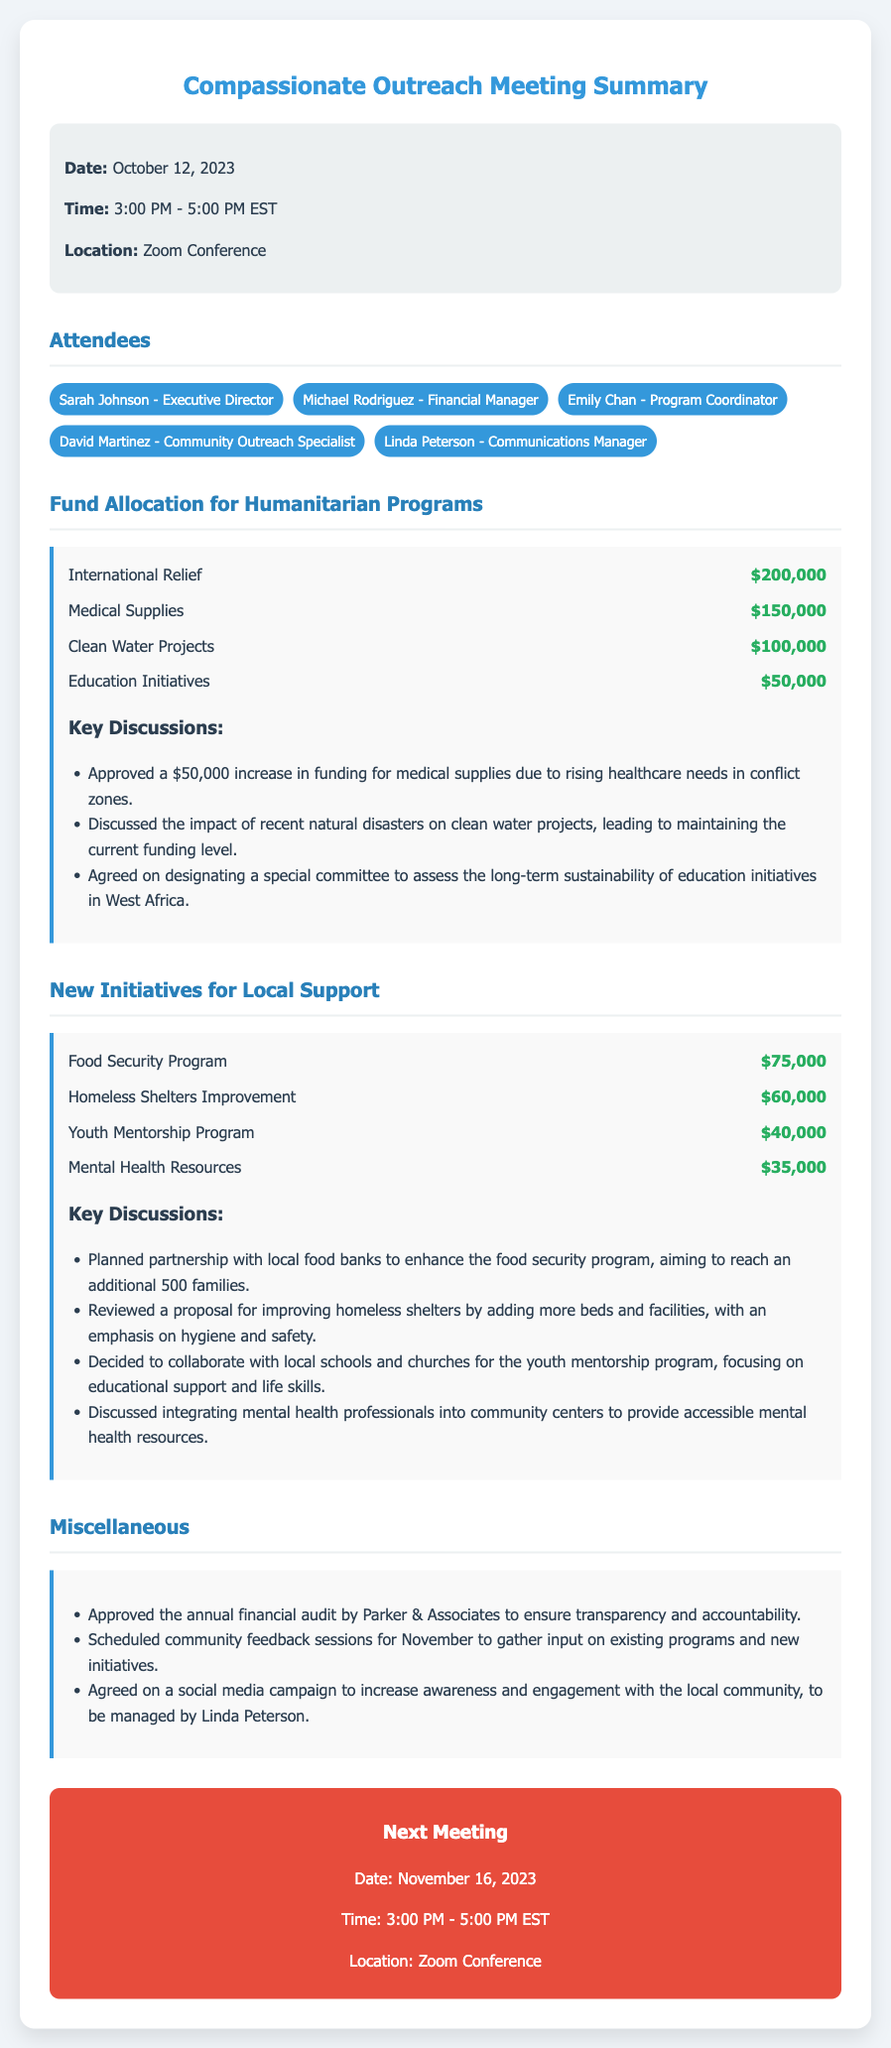What is the date of the meeting? The date of the meeting is specifically stated in the document as October 12, 2023.
Answer: October 12, 2023 Who is the Executive Director? The document lists Sarah Johnson as the Executive Director among the attendees.
Answer: Sarah Johnson How much was allocated for Medical Supplies? The allocation for Medical Supplies is noted in the document as $150,000.
Answer: $150,000 What is the amount for the Food Security Program? The amount allocated for the Food Security Program is mentioned in the document as $75,000.
Answer: $75,000 Which initiative is aimed at enhancing mental health resources? The initiative for mental health resources is specifically named in the document as Mental Health Resources.
Answer: Mental Health Resources Why was the funding for medical supplies increased? The document mentions that the funding was increased due to rising healthcare needs in conflict zones, which requires reasoning about the context provided.
Answer: Rising healthcare needs in conflict zones What is the purpose of the scheduled community feedback sessions? The document states that the purpose is to gather input on existing programs and new initiatives, requiring understanding of the meeting’s goals.
Answer: Gather input on existing programs and new initiatives When is the next meeting scheduled? The next meeting date is included in the document as November 16, 2023.
Answer: November 16, 2023 